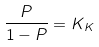Convert formula to latex. <formula><loc_0><loc_0><loc_500><loc_500>\frac { P } { 1 - P } = K _ { K }</formula> 